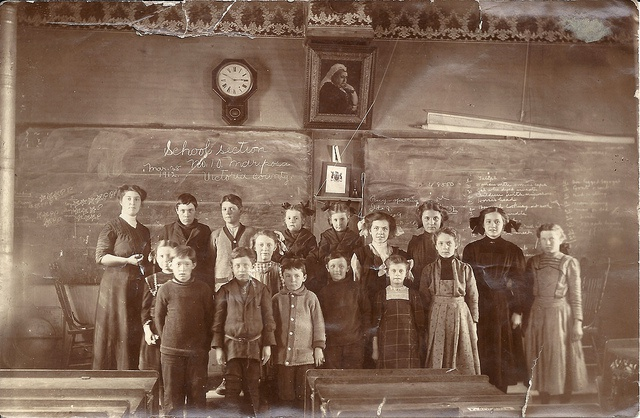Describe the objects in this image and their specific colors. I can see people in black, maroon, and gray tones, people in black, gray, and brown tones, people in black, maroon, and brown tones, people in black, maroon, and gray tones, and people in black, maroon, and gray tones in this image. 